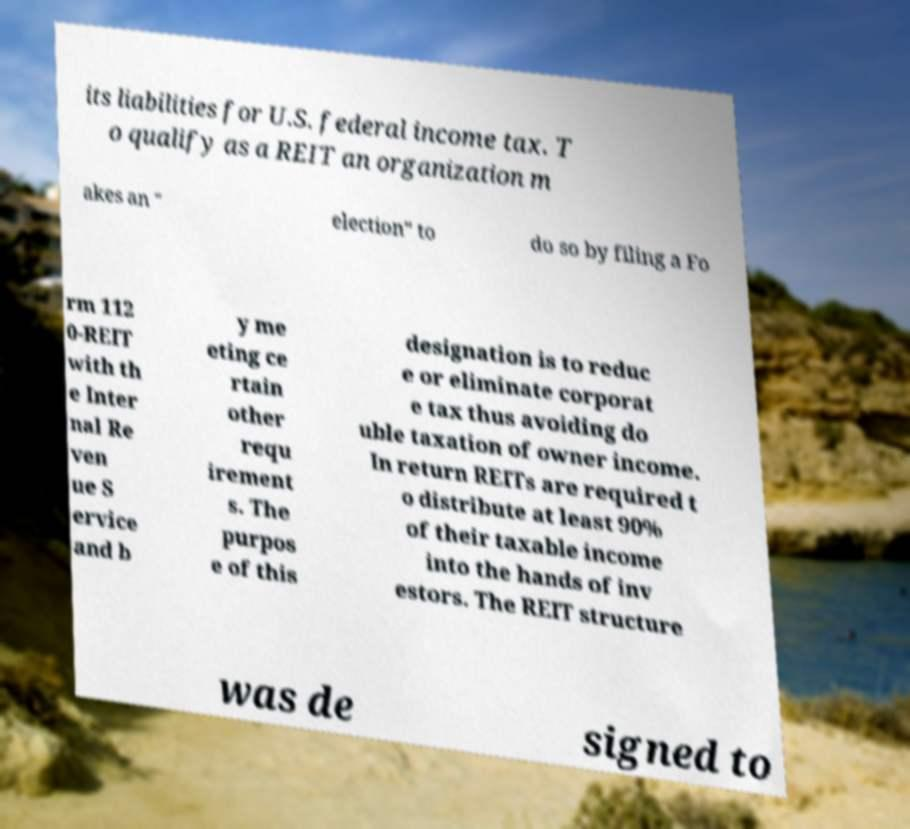Can you read and provide the text displayed in the image?This photo seems to have some interesting text. Can you extract and type it out for me? its liabilities for U.S. federal income tax. T o qualify as a REIT an organization m akes an " election" to do so by filing a Fo rm 112 0-REIT with th e Inter nal Re ven ue S ervice and b y me eting ce rtain other requ irement s. The purpos e of this designation is to reduc e or eliminate corporat e tax thus avoiding do uble taxation of owner income. In return REITs are required t o distribute at least 90% of their taxable income into the hands of inv estors. The REIT structure was de signed to 